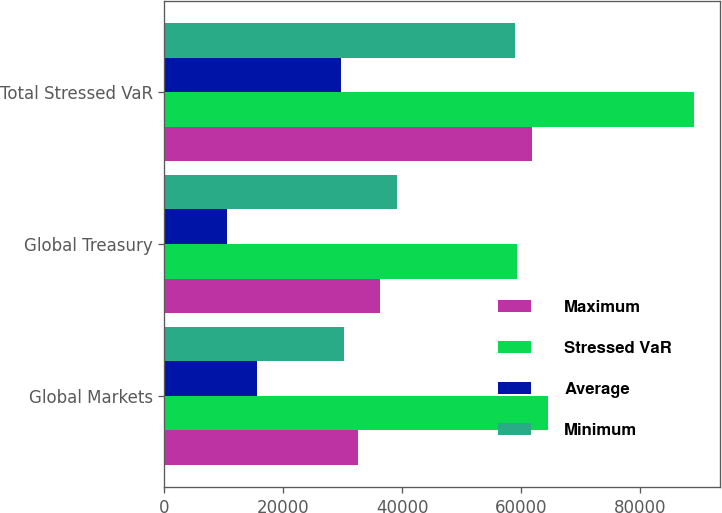<chart> <loc_0><loc_0><loc_500><loc_500><stacked_bar_chart><ecel><fcel>Global Markets<fcel>Global Treasury<fcel>Total Stressed VaR<nl><fcel>Maximum<fcel>32639<fcel>36344<fcel>61874<nl><fcel>Stressed VaR<fcel>64510<fcel>59253<fcel>89053<nl><fcel>Average<fcel>15625<fcel>10454<fcel>29689<nl><fcel>Minimum<fcel>30255<fcel>39050<fcel>58945<nl></chart> 